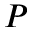Convert formula to latex. <formula><loc_0><loc_0><loc_500><loc_500>P</formula> 